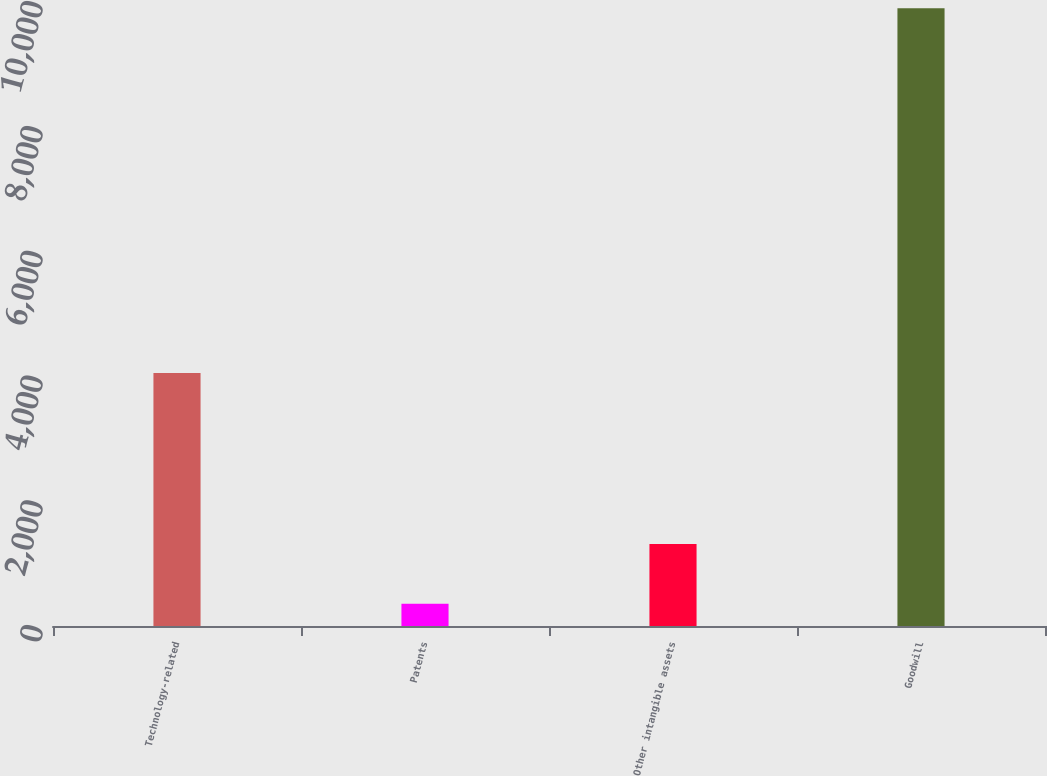Convert chart to OTSL. <chart><loc_0><loc_0><loc_500><loc_500><bar_chart><fcel>Technology-related<fcel>Patents<fcel>Other intangible assets<fcel>Goodwill<nl><fcel>4054<fcel>358<fcel>1312.2<fcel>9900<nl></chart> 